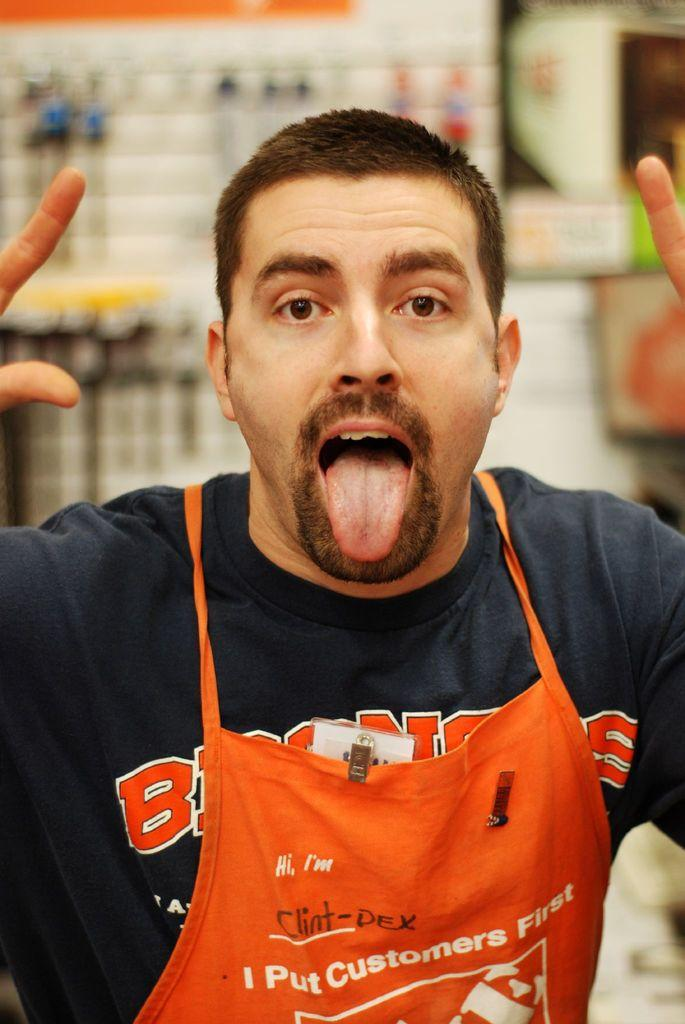<image>
Render a clear and concise summary of the photo. A man wearing an apron that reads, I put customers first. 